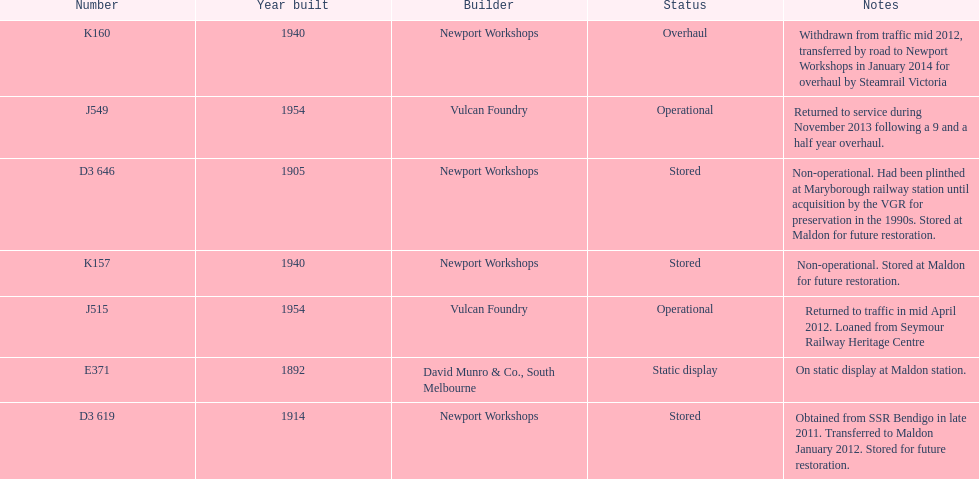Which are the only trains still in service? J515, J549. 